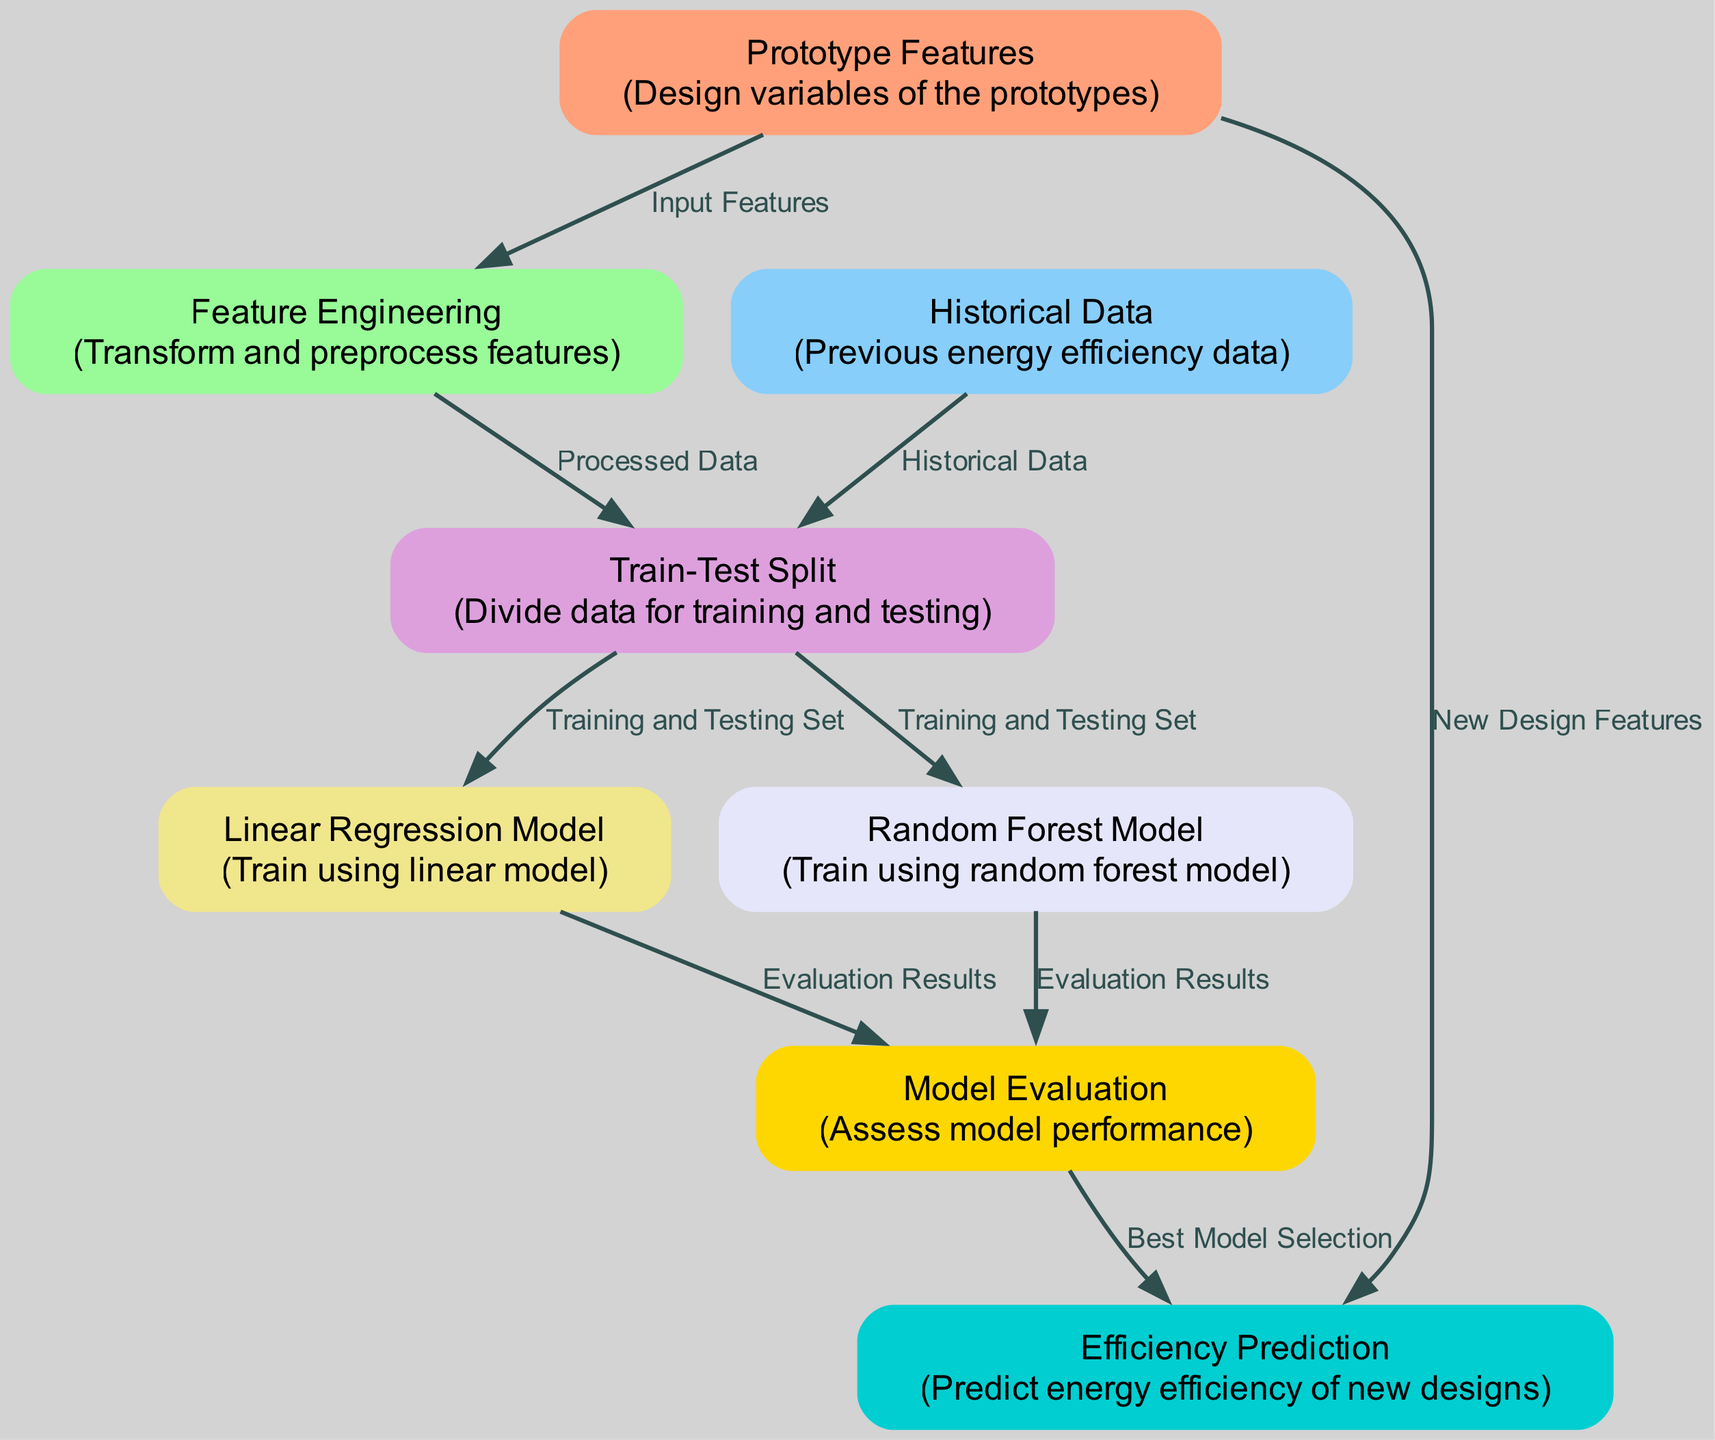What is the first node in the diagram? The first node in the diagram is "Prototype Features". It is indicated as the starting point of the processing flow, and it represents the design variables of the prototypes.
Answer: Prototype Features How many nodes are there in total? The diagram contains eight nodes. Each node serves a distinct purpose in the energy efficiency prediction process, from features to model evaluation.
Answer: Eight What type of model is used for prediction in the diagram? The diagram indicates that the "Linear Regression Model" and "Random Forest Model" are both used, but the context specifically mentions the purpose of these models, which is to make predictions based on the training data.
Answer: Linear Regression Model, Random Forest Model Which node is responsible for evaluating model performance? The "Model Evaluation" node is responsible for assessing the performance of the trained models. It captures the results from both the linear regression and random forest models to determine the best-performing one.
Answer: Model Evaluation What is the relationship between "Train-Test Split" and the "Historical Data"? "Train-Test Split" has an incoming edge from "Historical Data", indicating that historical data is used to create the training and testing sets for model training.
Answer: Historical Data Which node leads directly to "Efficiency Prediction"? The "Model Evaluation" node leads directly to "Efficiency Prediction". This shows that the selection of the best model based on the evaluation results contributes directly to the prediction of energy efficiency for new designs.
Answer: Model Evaluation How many different models are trained as per the diagram? According to the diagram, two different models are trained: the "Linear Regression Model" and the "Random Forest Model". Each model is derived from the same training and testing sets generated earlier in the process.
Answer: Two Which node provides the input features? The input features to the diagram come from the "Prototype Features" node. This node contains the design variables necessary for energy efficiency predictions.
Answer: Prototype Features What color represents the "Model Evaluation" node in the diagram? The "Model Evaluation" node is represented in gold color according to the specified color scheme in the diagram. This visually distinguishes it from other nodes.
Answer: Gold 